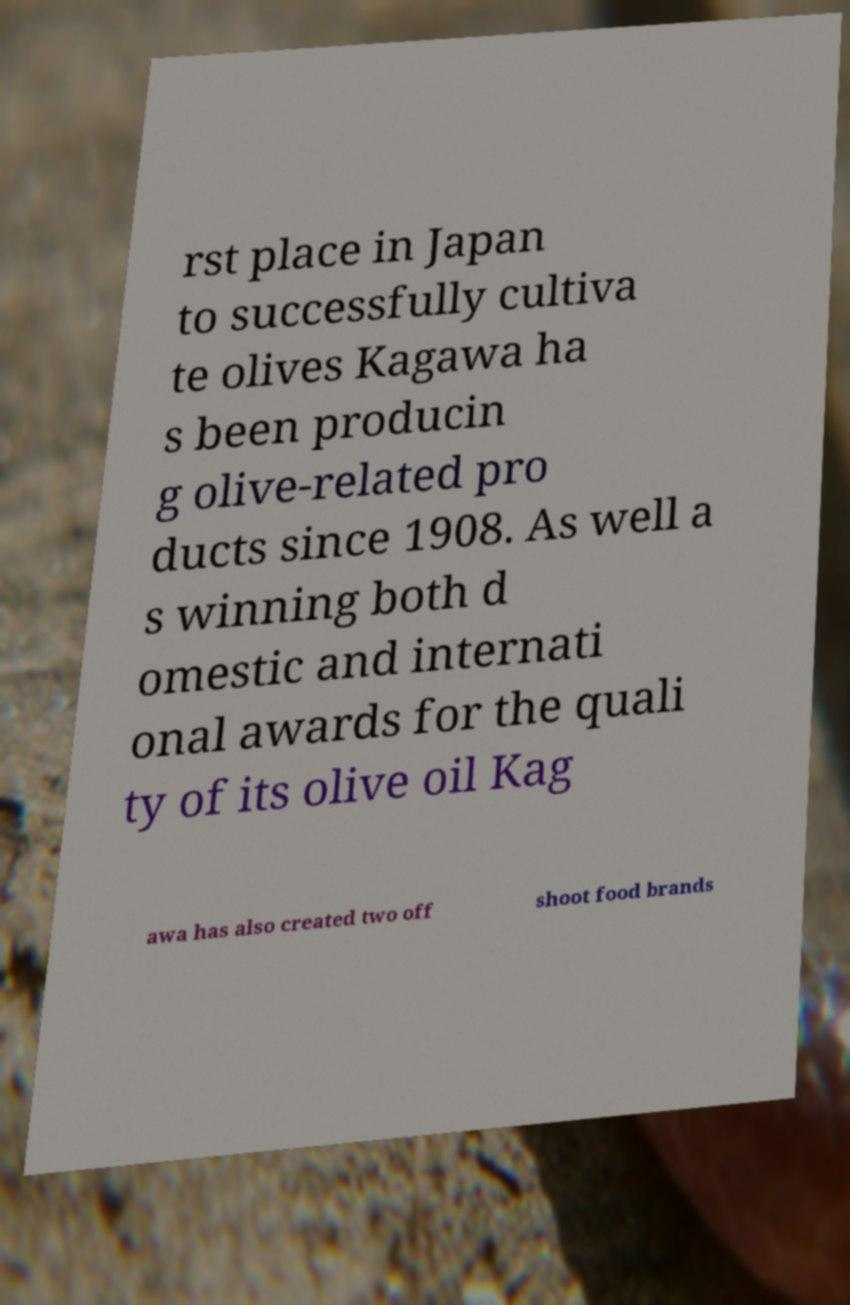There's text embedded in this image that I need extracted. Can you transcribe it verbatim? rst place in Japan to successfully cultiva te olives Kagawa ha s been producin g olive-related pro ducts since 1908. As well a s winning both d omestic and internati onal awards for the quali ty of its olive oil Kag awa has also created two off shoot food brands 